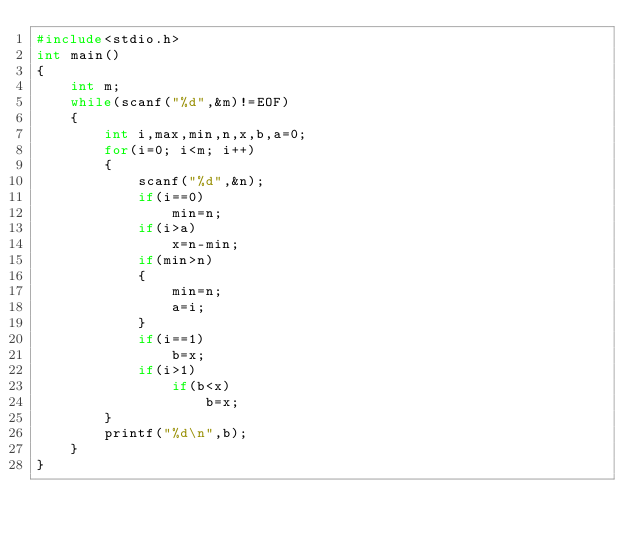Convert code to text. <code><loc_0><loc_0><loc_500><loc_500><_C_>#include<stdio.h>
int main()
{
    int m;
    while(scanf("%d",&m)!=EOF)
    {
        int i,max,min,n,x,b,a=0;
        for(i=0; i<m; i++)
        {
            scanf("%d",&n);
            if(i==0)
                min=n;
            if(i>a)
                x=n-min;
            if(min>n)
            {
                min=n;
                a=i;
            }
            if(i==1)
                b=x;
            if(i>1)
                if(b<x)
                    b=x;
        }
        printf("%d\n",b);
    }
}


</code> 